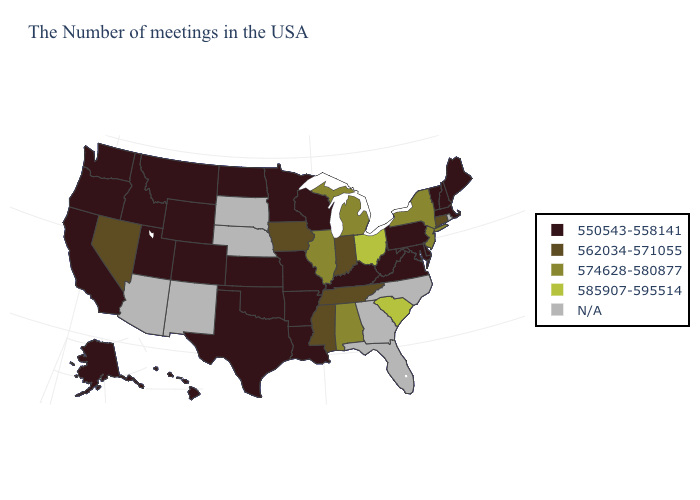Among the states that border Wisconsin , which have the highest value?
Concise answer only. Michigan, Illinois. What is the value of Pennsylvania?
Concise answer only. 550543-558141. What is the highest value in the USA?
Answer briefly. 585907-595514. What is the lowest value in the Northeast?
Write a very short answer. 550543-558141. What is the highest value in the Northeast ?
Short answer required. 574628-580877. Does Mississippi have the highest value in the USA?
Short answer required. No. Name the states that have a value in the range 550543-558141?
Write a very short answer. Maine, Massachusetts, New Hampshire, Vermont, Delaware, Maryland, Pennsylvania, Virginia, West Virginia, Kentucky, Wisconsin, Louisiana, Missouri, Arkansas, Minnesota, Kansas, Oklahoma, Texas, North Dakota, Wyoming, Colorado, Utah, Montana, Idaho, California, Washington, Oregon, Alaska, Hawaii. Is the legend a continuous bar?
Write a very short answer. No. Is the legend a continuous bar?
Short answer required. No. Does Indiana have the lowest value in the USA?
Write a very short answer. No. Name the states that have a value in the range 550543-558141?
Concise answer only. Maine, Massachusetts, New Hampshire, Vermont, Delaware, Maryland, Pennsylvania, Virginia, West Virginia, Kentucky, Wisconsin, Louisiana, Missouri, Arkansas, Minnesota, Kansas, Oklahoma, Texas, North Dakota, Wyoming, Colorado, Utah, Montana, Idaho, California, Washington, Oregon, Alaska, Hawaii. What is the value of Delaware?
Short answer required. 550543-558141. 